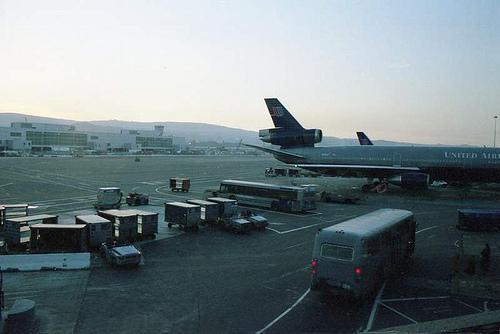How many buses are in the photo?
Give a very brief answer. 2. How many zebra heads can you see in this scene?
Give a very brief answer. 0. 